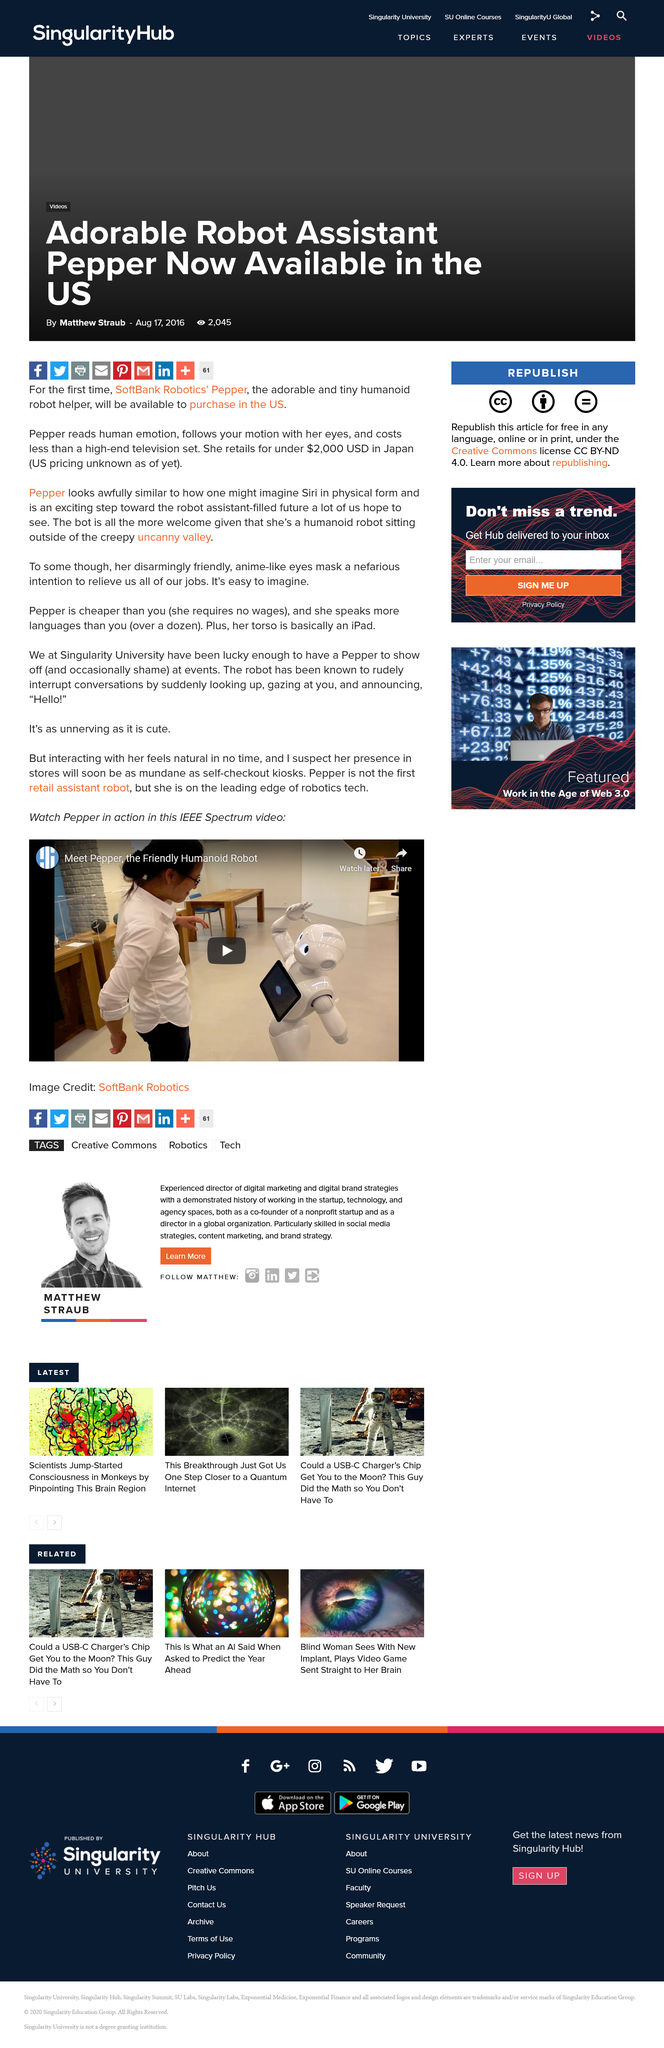Give some essential details in this illustration. Pepper is capable of speaking over a dozen languages. In the video below, you can watch Pepper in action, as she demonstrates her capabilities and shows what she is capable of. Interacting with Pepper feels natural and intuitive, allowing users to quickly and easily adapt to the robot's presence in their environment. 